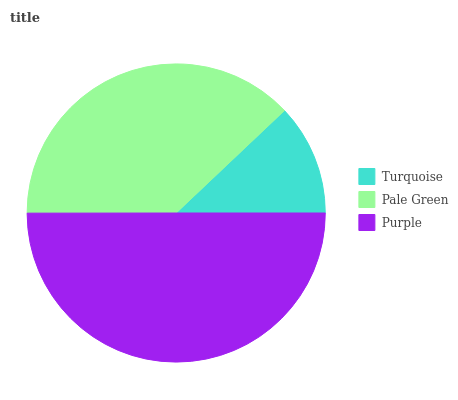Is Turquoise the minimum?
Answer yes or no. Yes. Is Purple the maximum?
Answer yes or no. Yes. Is Pale Green the minimum?
Answer yes or no. No. Is Pale Green the maximum?
Answer yes or no. No. Is Pale Green greater than Turquoise?
Answer yes or no. Yes. Is Turquoise less than Pale Green?
Answer yes or no. Yes. Is Turquoise greater than Pale Green?
Answer yes or no. No. Is Pale Green less than Turquoise?
Answer yes or no. No. Is Pale Green the high median?
Answer yes or no. Yes. Is Pale Green the low median?
Answer yes or no. Yes. Is Turquoise the high median?
Answer yes or no. No. Is Turquoise the low median?
Answer yes or no. No. 